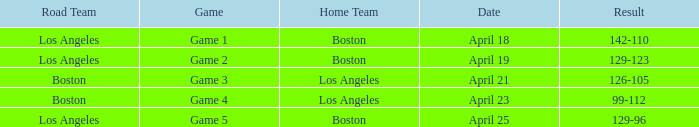WHAT IS THE DATE WITH BOSTON ROAD TEAM AND 126-105 RESULT? April 21. 